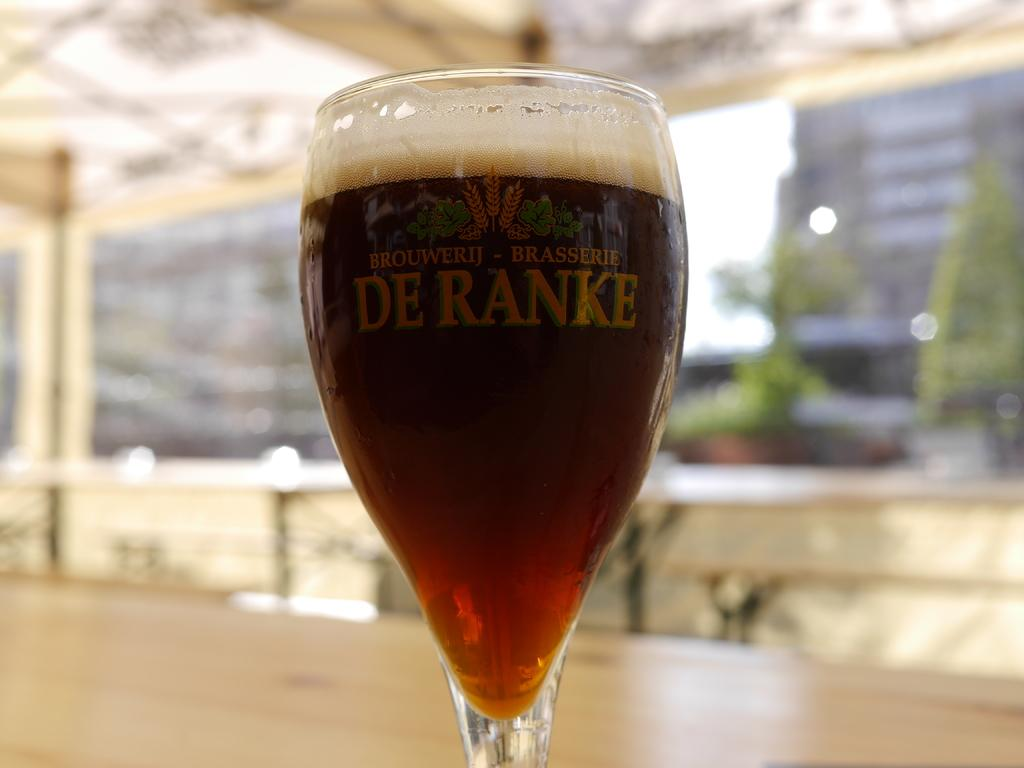Provide a one-sentence caption for the provided image. A glass with the words DE RANKE on it is full. 